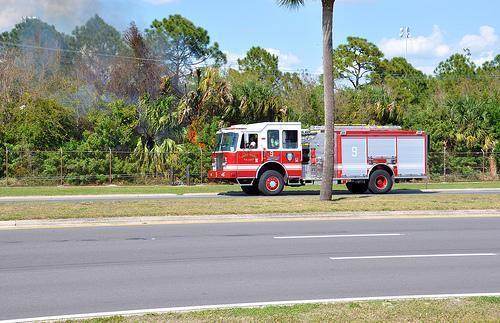How many fire trucks are there?
Give a very brief answer. 1. 